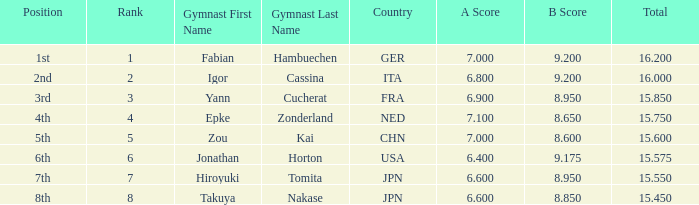Which gymnast had a b score of 8.95 and an a score less than 6.9 Hiroyuki Tomita ( JPN ). 